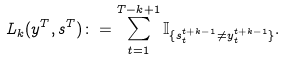Convert formula to latex. <formula><loc_0><loc_0><loc_500><loc_500>L _ { k } ( y ^ { T } , s ^ { T } ) \colon = \sum _ { t = 1 } ^ { T - k + 1 } \mathbb { I } _ { \{ s _ { t } ^ { t + k - 1 } \neq y _ { t } ^ { t + k - 1 } \} } .</formula> 